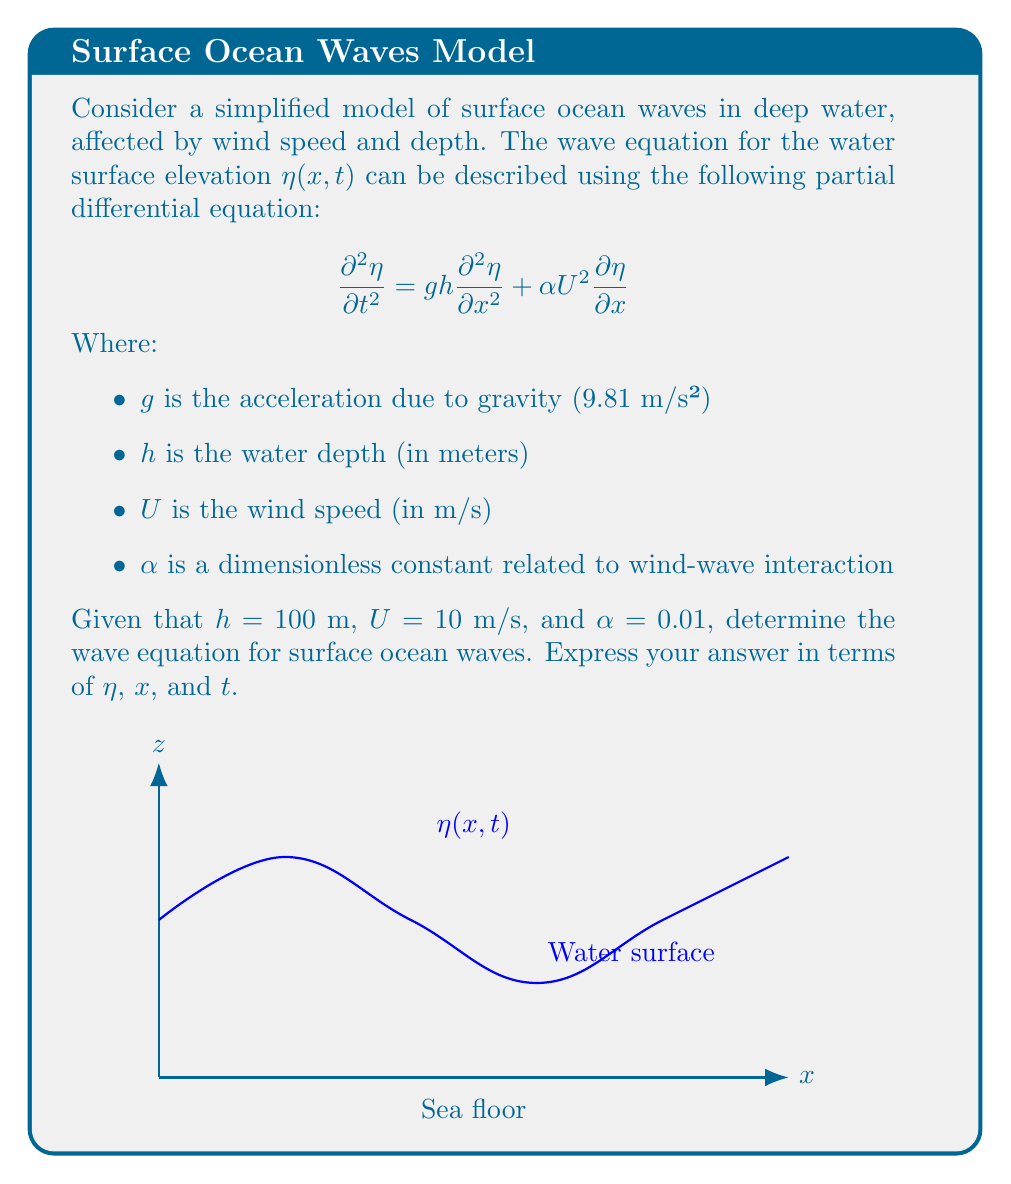Can you solve this math problem? Let's approach this step-by-step:

1) We start with the given wave equation:

   $$\frac{\partial^2 \eta}{\partial t^2} = g h \frac{\partial^2 \eta}{\partial x^2} + \alpha U^2 \frac{\partial \eta}{\partial x}$$

2) We're given the following values:
   - $g = 9.81$ m/s² (acceleration due to gravity)
   - $h = 100$ m (water depth)
   - $U = 10$ m/s (wind speed)
   - $\alpha = 0.01$ (dimensionless constant)

3) Let's substitute these values into the equation:

   $$\frac{\partial^2 \eta}{\partial t^2} = 9.81 \cdot 100 \frac{\partial^2 \eta}{\partial x^2} + 0.01 \cdot 10^2 \frac{\partial \eta}{\partial x}$$

4) Simplify:

   $$\frac{\partial^2 \eta}{\partial t^2} = 981 \frac{\partial^2 \eta}{\partial x^2} + 1 \frac{\partial \eta}{\partial x}$$

5) This is our final wave equation for surface ocean waves under the given conditions.
Answer: $$\frac{\partial^2 \eta}{\partial t^2} = 981 \frac{\partial^2 \eta}{\partial x^2} + \frac{\partial \eta}{\partial x}$$ 